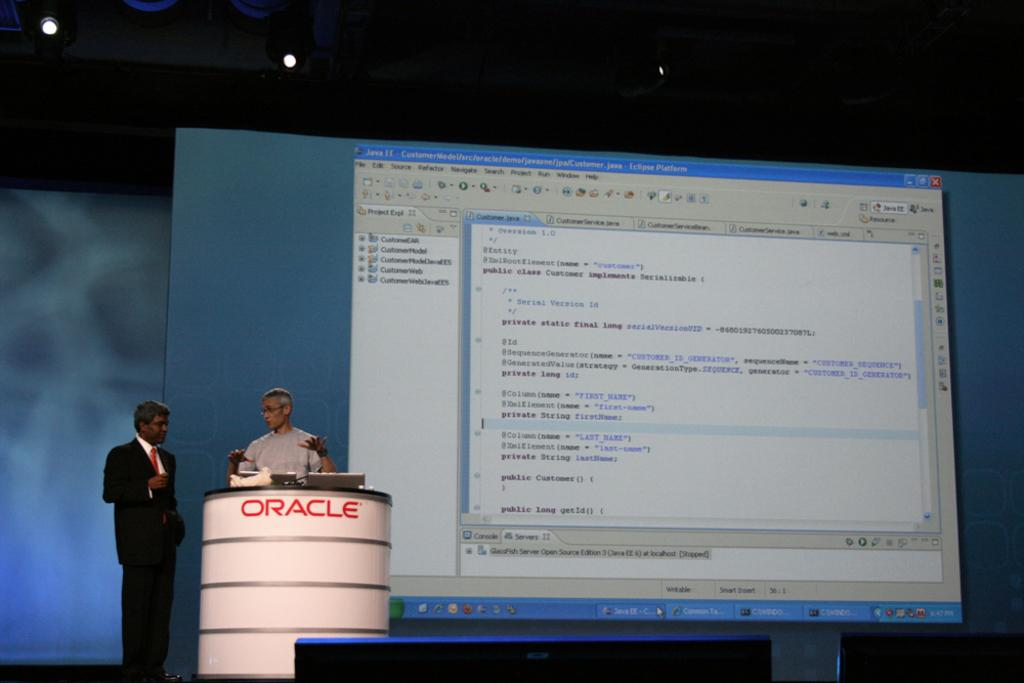<image>
Give a short and clear explanation of the subsequent image. Two men present a computer screen presentation from an ORACLE podium. 